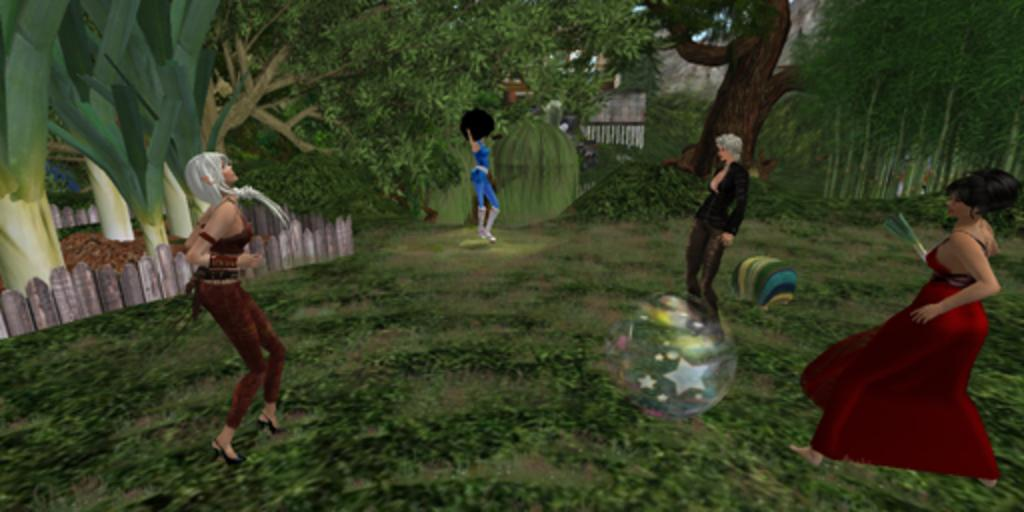What is depicted in the picture? There is a cartoon image of four girls in the picture. Where are the girls standing? The girls are standing in a garden. What can be seen in the background of the image? There are trees visible in the background. What type of trees are on the left side of the image? There are banana trees on the left side of the image. Can you provide an example of a fang in the image? There are no fangs present in the image; it features a cartoon image of four girls standing in a garden with banana trees in the background. 